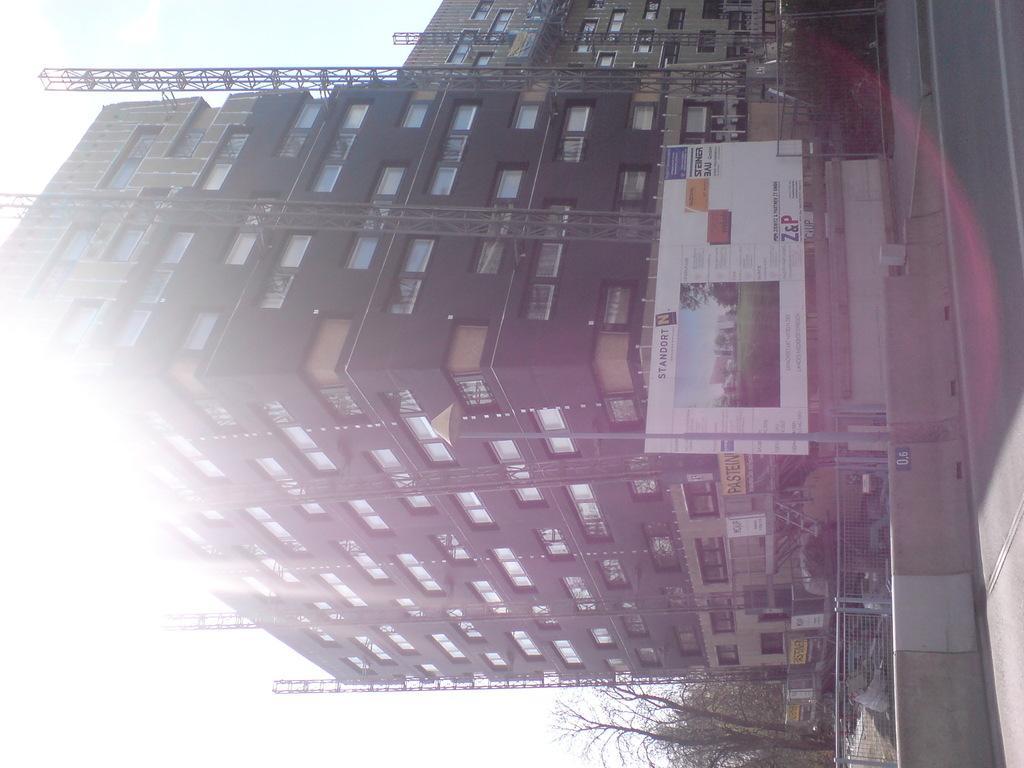Please provide a concise description of this image. In this picture we can see few buildings, metal rods, trees, fences and hoardings. 